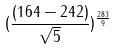<formula> <loc_0><loc_0><loc_500><loc_500>( \frac { ( 1 6 4 - 2 4 2 ) } { \sqrt { 5 } } ) ^ { \frac { 2 8 3 } { 9 } }</formula> 